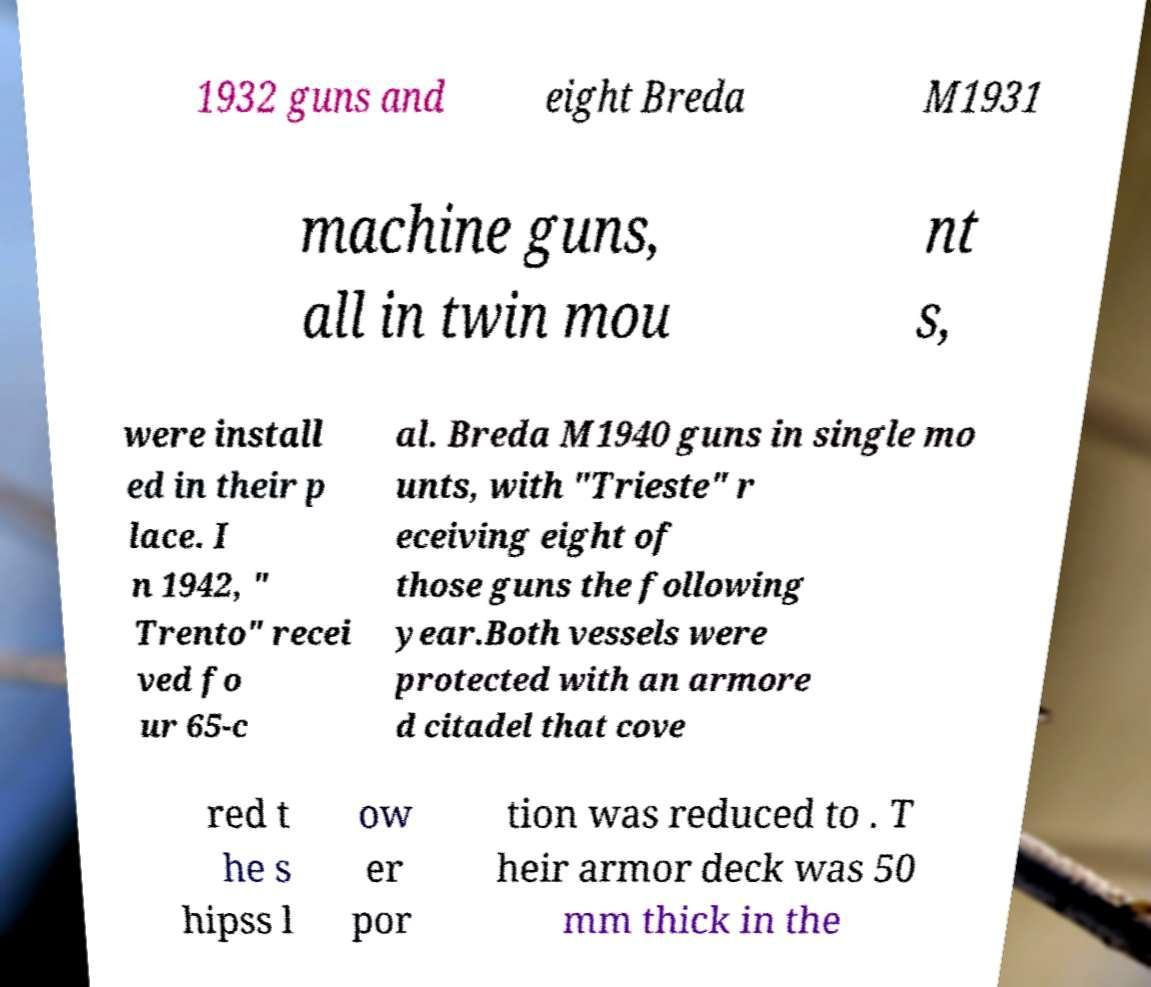Can you accurately transcribe the text from the provided image for me? 1932 guns and eight Breda M1931 machine guns, all in twin mou nt s, were install ed in their p lace. I n 1942, " Trento" recei ved fo ur 65-c al. Breda M1940 guns in single mo unts, with "Trieste" r eceiving eight of those guns the following year.Both vessels were protected with an armore d citadel that cove red t he s hipss l ow er por tion was reduced to . T heir armor deck was 50 mm thick in the 